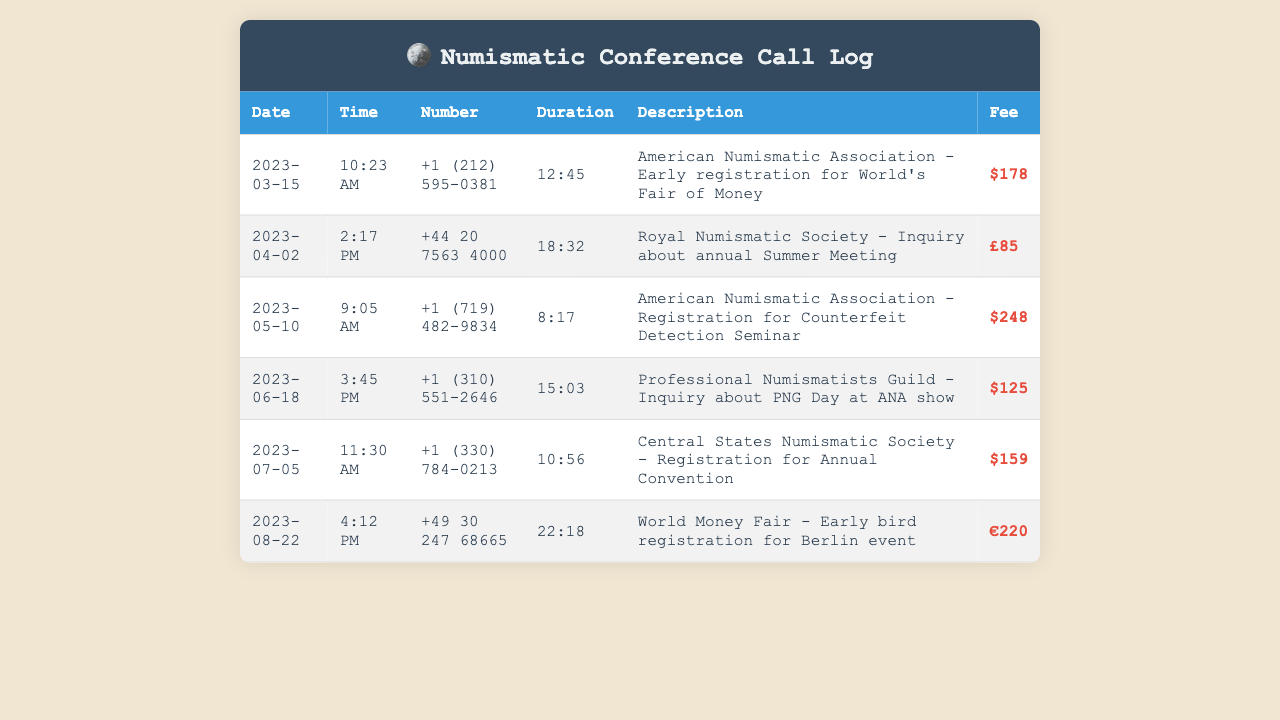what was the registration fee for the Counterfeit Detection Seminar? The registration fee for the Counterfeit Detection Seminar is specifically listed in the document.
Answer: $248 on what date was the inquiry about the annual Summer Meeting made? The date of the inquiry about the annual Summer Meeting can be found in the entry related to the Royal Numismatic Society.
Answer: 2023-04-02 how long was the call regarding the World's Fair of Money registration? The duration of the call regarding the World's Fair of Money is detailed in the corresponding entry.
Answer: 12:45 how many calls were made to events held by the American Numismatic Association? Counting the entries involving the American Numismatic Association provides the answer.
Answer: 2 what time was the call made to the World Money Fair? The time of the call to the World Money Fair is indicated in its respective entry.
Answer: 4:12 PM which event had the highest registration fee? Comparing the registration fees for each entry allows us to determine which one was the highest.
Answer: $248 which organization was contacted regarding the PNG Day at ANA show? The organization for the inquiry about the PNG Day at the ANA show is found in the description.
Answer: Professional Numismatists Guild what was the total sum of registration fees for the calls listed? The total sum can be calculated by adding all registration fees from the document.
Answer: $1,030 how many different countries are represented in the call numbers? The document includes calls from various countries, which can be counted from the entries.
Answer: 3 